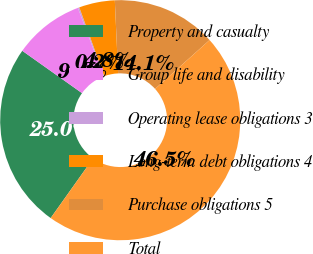Convert chart. <chart><loc_0><loc_0><loc_500><loc_500><pie_chart><fcel>Property and casualty<fcel>Group life and disability<fcel>Operating lease obligations 3<fcel>Long-term debt obligations 4<fcel>Purchase obligations 5<fcel>Total<nl><fcel>24.98%<fcel>9.45%<fcel>0.2%<fcel>4.82%<fcel>14.08%<fcel>46.47%<nl></chart> 